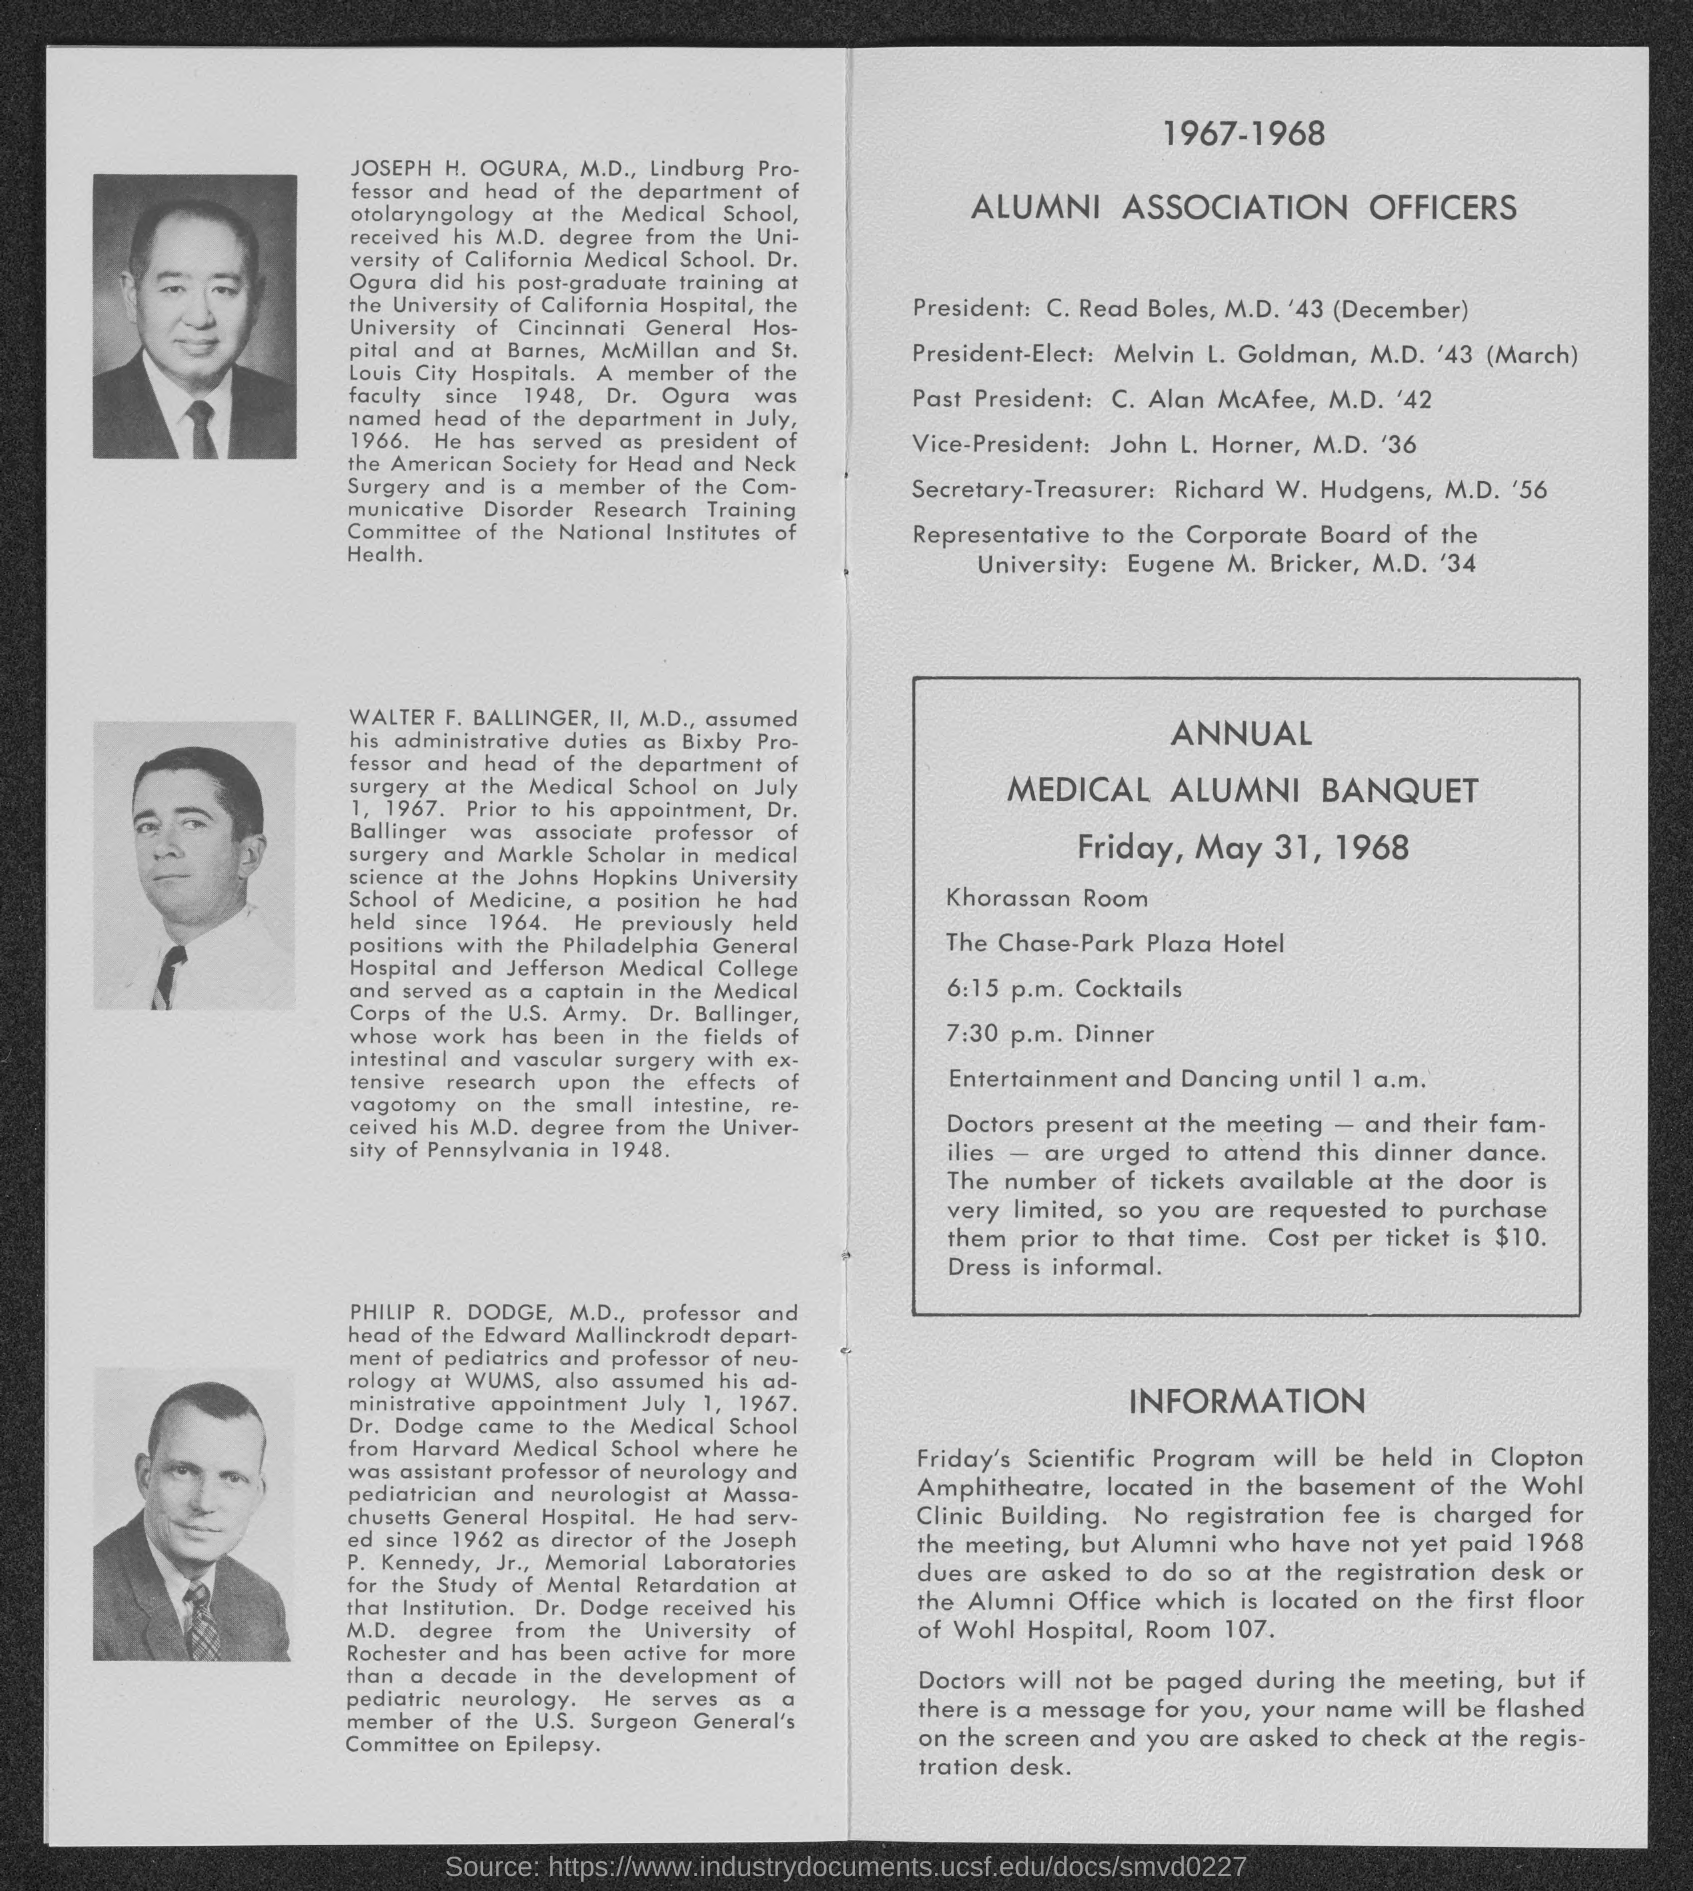Draw attention to some important aspects in this diagram. The representative to the corporate board of the university is Eugene M. Bricker, M.D. 